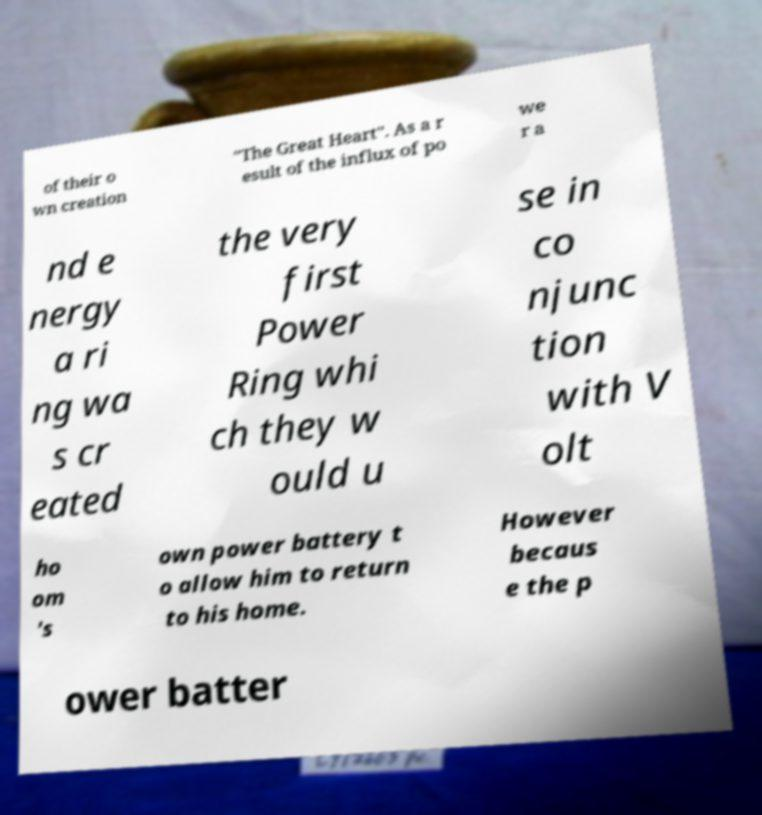What messages or text are displayed in this image? I need them in a readable, typed format. of their o wn creation "The Great Heart". As a r esult of the influx of po we r a nd e nergy a ri ng wa s cr eated the very first Power Ring whi ch they w ould u se in co njunc tion with V olt ho om 's own power battery t o allow him to return to his home. However becaus e the p ower batter 